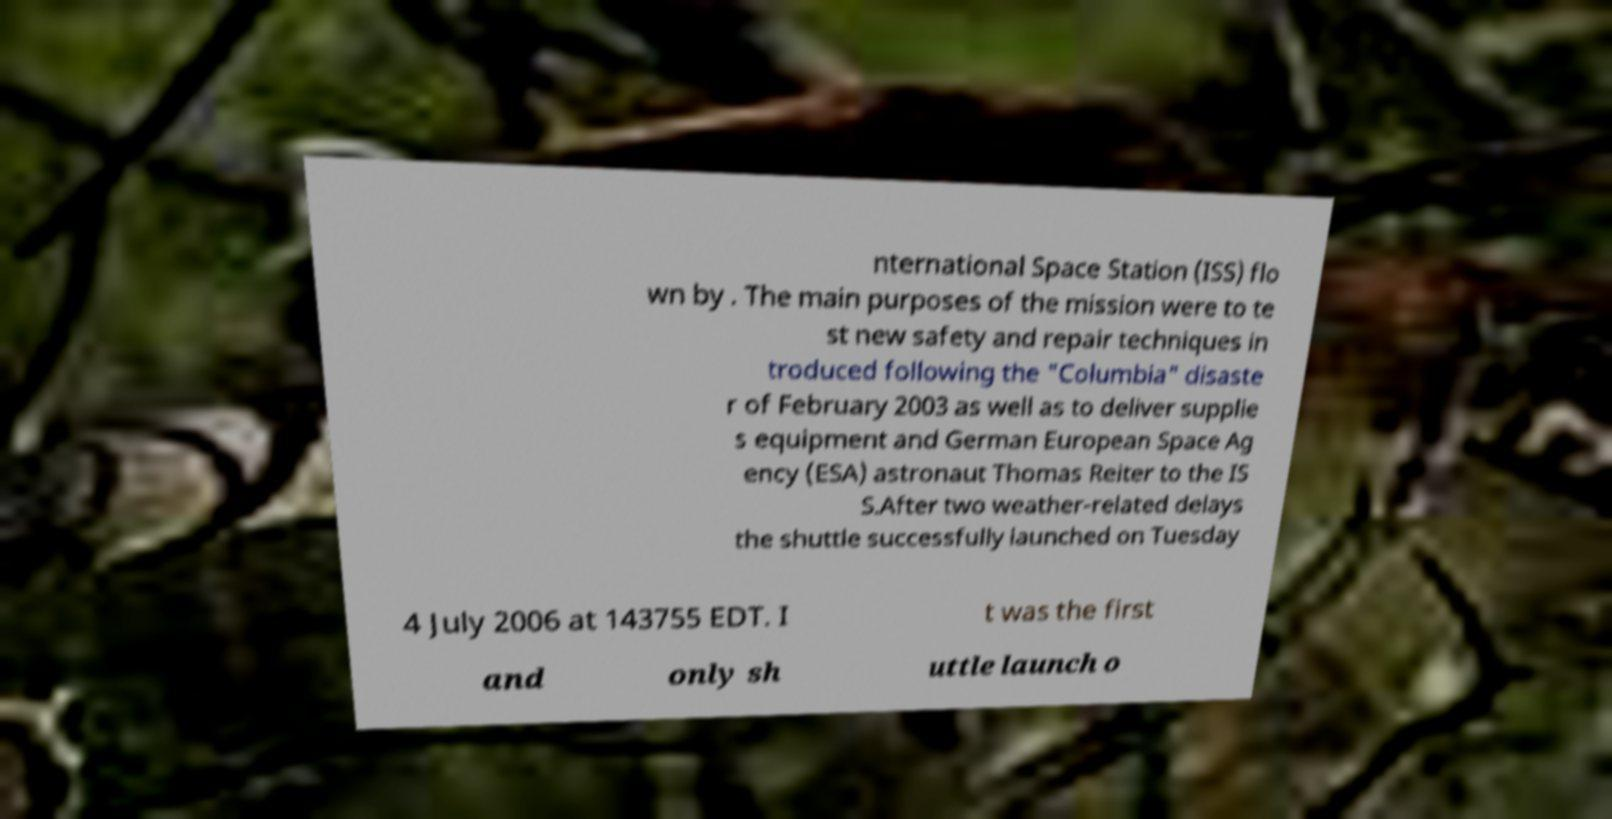I need the written content from this picture converted into text. Can you do that? nternational Space Station (ISS) flo wn by . The main purposes of the mission were to te st new safety and repair techniques in troduced following the "Columbia" disaste r of February 2003 as well as to deliver supplie s equipment and German European Space Ag ency (ESA) astronaut Thomas Reiter to the IS S.After two weather-related delays the shuttle successfully launched on Tuesday 4 July 2006 at 143755 EDT. I t was the first and only sh uttle launch o 